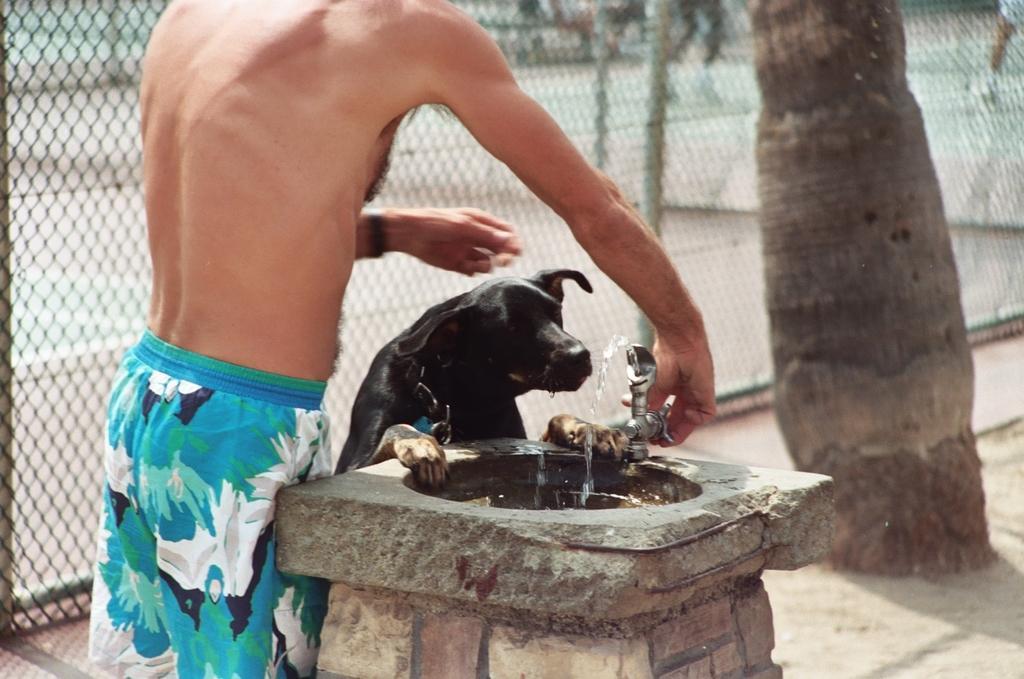How would you summarize this image in a sentence or two? Here in this picture we can see a person standing on the ground and in front him we can see a sink and a tap, as we can see he is opening the tap and beside him we can see a dog present over there, trying to drink the water and beside them we can see a fencing present and in front of them we can see a trunk of a tree present over there. 